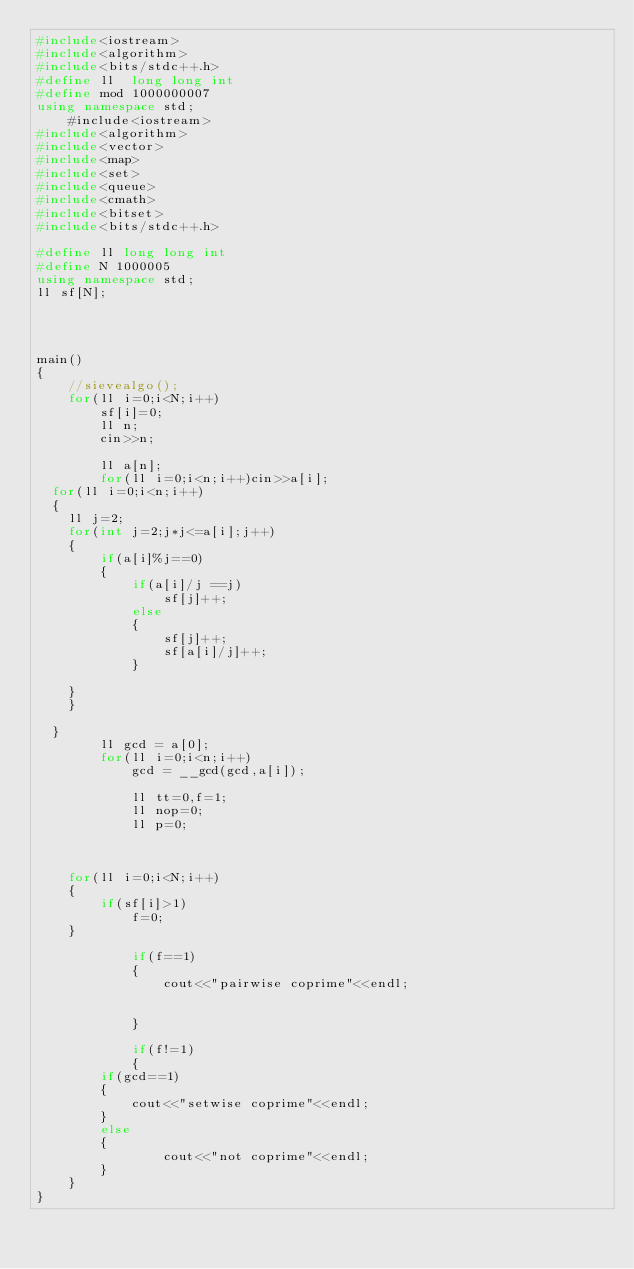Convert code to text. <code><loc_0><loc_0><loc_500><loc_500><_C++_>#include<iostream>
#include<algorithm>
#include<bits/stdc++.h>
#define ll  long long int
#define mod 1000000007
using namespace std;
	#include<iostream>
#include<algorithm>
#include<vector>
#include<map>
#include<set>
#include<queue>
#include<cmath>
#include<bitset>
#include<bits/stdc++.h>

#define ll long long int
#define N 1000005
using namespace std;
ll sf[N];




main()
{
	//sievealgo();
    for(ll i=0;i<N;i++)
    	sf[i]=0;
		ll n;
		cin>>n;
		
		ll a[n];
		for(ll i=0;i<n;i++)cin>>a[i];
  for(ll i=0;i<n;i++)
  {	
    ll j=2;
    for(int j=2;j*j<=a[i];j++)
    {
    	if(a[i]%j==0)
    	{
			if(a[i]/j ==j)	
		        sf[j]++;
		    else
		    {
		    	sf[j]++;
		    	sf[a[i]/j]++;
			}
    	
	}
	}
      
  }
		ll gcd = a[0];
		for(ll i=0;i<n;i++)
			gcd = __gcd(gcd,a[i]);
  
			ll tt=0,f=1;
			ll nop=0;
			ll p=0;
			
  		
			
  	for(ll i=0;i<N;i++)
    {
     	if(sf[i]>1)
          	f=0;
    }
			
			if(f==1)
			{
				cout<<"pairwise coprime"<<endl;
						
						
			}
			
			if(f!=1)
			{
		if(gcd==1)
		{
			cout<<"setwise coprime"<<endl;
		}		
		else
		{
				cout<<"not coprime"<<endl;
		}
	}
}
</code> 